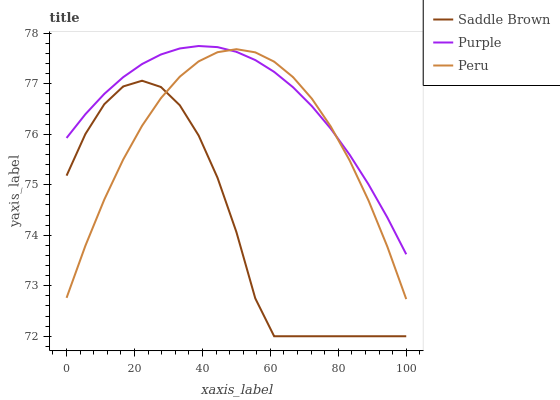Does Saddle Brown have the minimum area under the curve?
Answer yes or no. Yes. Does Purple have the maximum area under the curve?
Answer yes or no. Yes. Does Peru have the minimum area under the curve?
Answer yes or no. No. Does Peru have the maximum area under the curve?
Answer yes or no. No. Is Purple the smoothest?
Answer yes or no. Yes. Is Saddle Brown the roughest?
Answer yes or no. Yes. Is Peru the smoothest?
Answer yes or no. No. Is Peru the roughest?
Answer yes or no. No. Does Saddle Brown have the lowest value?
Answer yes or no. Yes. Does Peru have the lowest value?
Answer yes or no. No. Does Purple have the highest value?
Answer yes or no. Yes. Does Peru have the highest value?
Answer yes or no. No. Is Saddle Brown less than Purple?
Answer yes or no. Yes. Is Purple greater than Saddle Brown?
Answer yes or no. Yes. Does Saddle Brown intersect Peru?
Answer yes or no. Yes. Is Saddle Brown less than Peru?
Answer yes or no. No. Is Saddle Brown greater than Peru?
Answer yes or no. No. Does Saddle Brown intersect Purple?
Answer yes or no. No. 